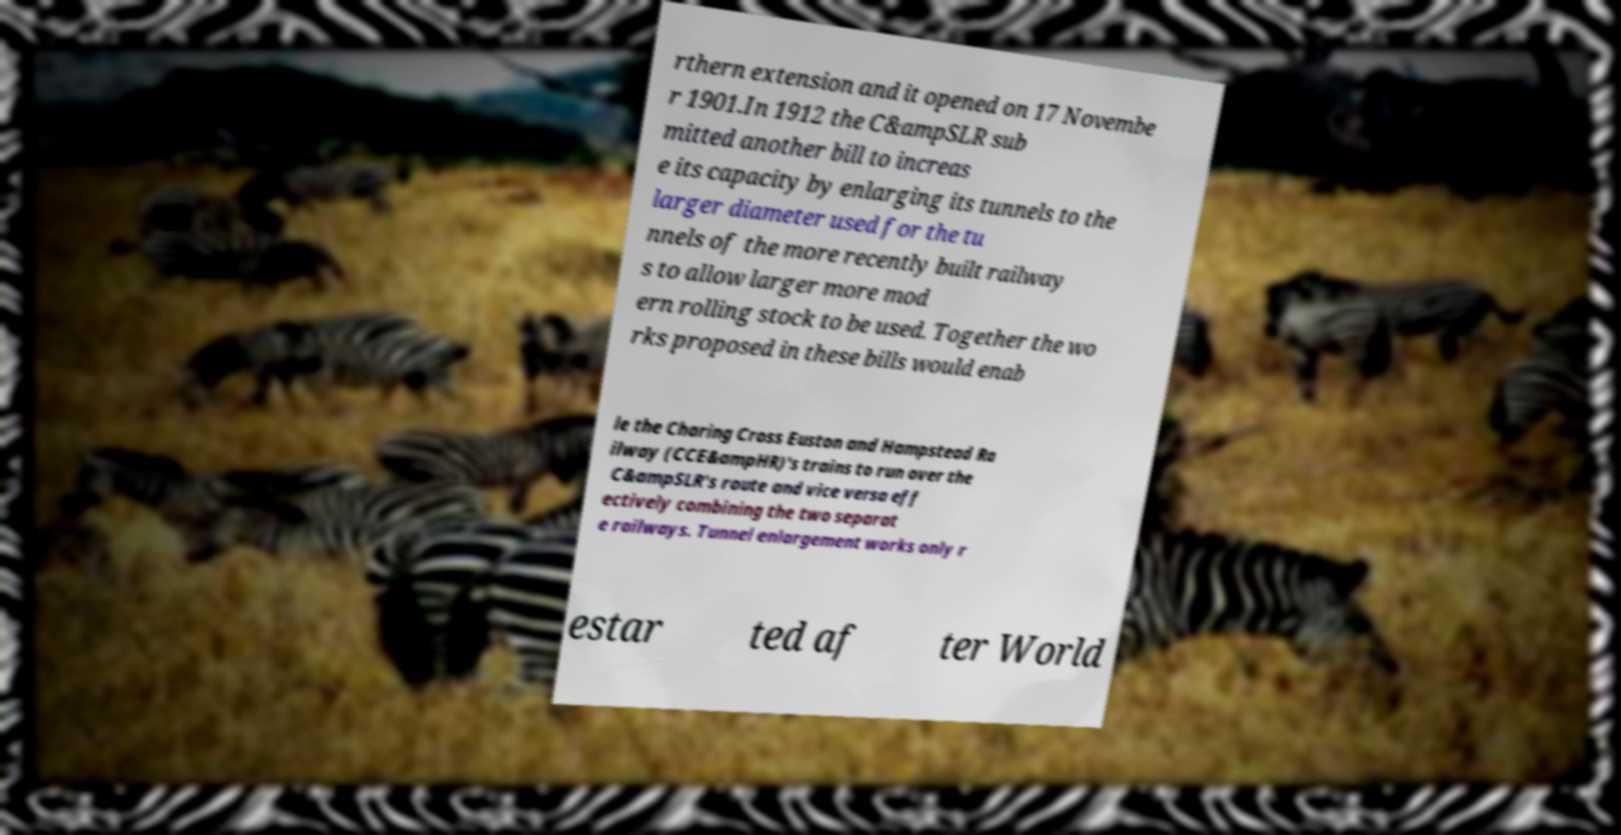For documentation purposes, I need the text within this image transcribed. Could you provide that? rthern extension and it opened on 17 Novembe r 1901.In 1912 the C&ampSLR sub mitted another bill to increas e its capacity by enlarging its tunnels to the larger diameter used for the tu nnels of the more recently built railway s to allow larger more mod ern rolling stock to be used. Together the wo rks proposed in these bills would enab le the Charing Cross Euston and Hampstead Ra ilway (CCE&ampHR)'s trains to run over the C&ampSLR's route and vice versa eff ectively combining the two separat e railways. Tunnel enlargement works only r estar ted af ter World 